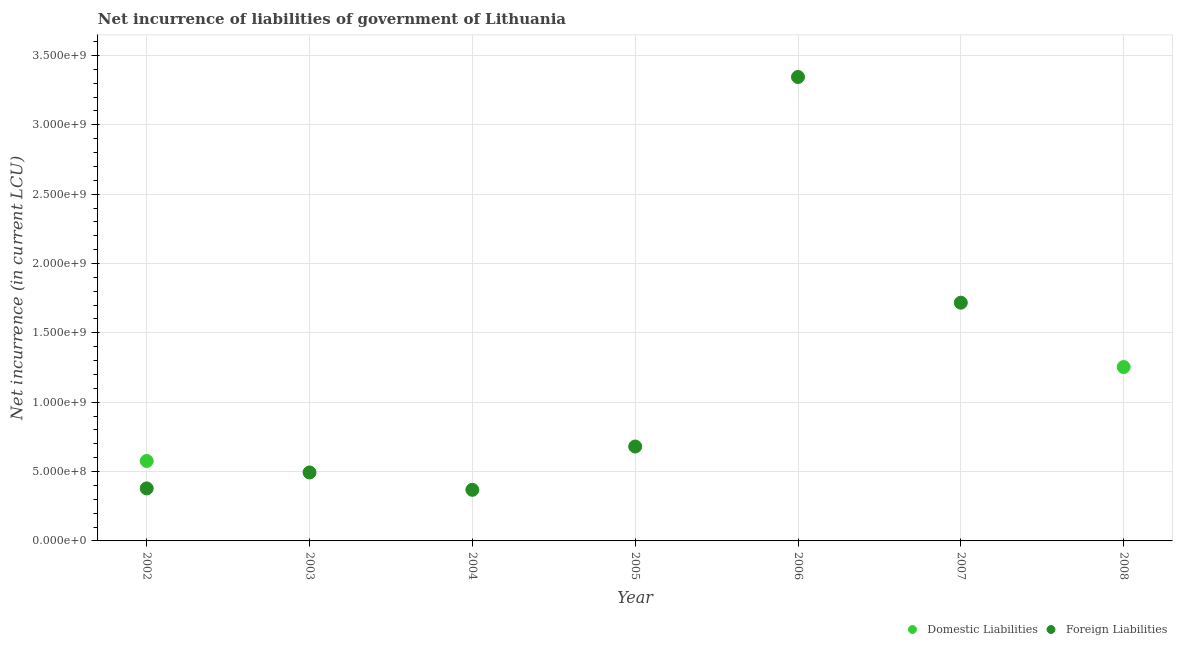What is the net incurrence of domestic liabilities in 2007?
Offer a very short reply. 0. Across all years, what is the maximum net incurrence of foreign liabilities?
Your response must be concise. 3.34e+09. Across all years, what is the minimum net incurrence of domestic liabilities?
Give a very brief answer. 0. In which year was the net incurrence of domestic liabilities maximum?
Keep it short and to the point. 2008. What is the total net incurrence of domestic liabilities in the graph?
Ensure brevity in your answer.  1.83e+09. What is the difference between the net incurrence of foreign liabilities in 2002 and that in 2006?
Your answer should be compact. -2.97e+09. What is the difference between the net incurrence of domestic liabilities in 2003 and the net incurrence of foreign liabilities in 2007?
Provide a succinct answer. -1.72e+09. What is the average net incurrence of foreign liabilities per year?
Ensure brevity in your answer.  9.98e+08. In the year 2002, what is the difference between the net incurrence of domestic liabilities and net incurrence of foreign liabilities?
Your answer should be compact. 1.98e+08. In how many years, is the net incurrence of foreign liabilities greater than 3300000000 LCU?
Keep it short and to the point. 1. What is the ratio of the net incurrence of foreign liabilities in 2002 to that in 2003?
Ensure brevity in your answer.  0.77. Is the net incurrence of foreign liabilities in 2002 less than that in 2003?
Offer a terse response. Yes. What is the difference between the highest and the second highest net incurrence of foreign liabilities?
Provide a short and direct response. 1.63e+09. What is the difference between the highest and the lowest net incurrence of domestic liabilities?
Offer a very short reply. 1.25e+09. Is the net incurrence of domestic liabilities strictly greater than the net incurrence of foreign liabilities over the years?
Make the answer very short. No. Is the net incurrence of foreign liabilities strictly less than the net incurrence of domestic liabilities over the years?
Make the answer very short. No. How many years are there in the graph?
Make the answer very short. 7. Are the values on the major ticks of Y-axis written in scientific E-notation?
Offer a very short reply. Yes. Does the graph contain any zero values?
Offer a terse response. Yes. Does the graph contain grids?
Make the answer very short. Yes. Where does the legend appear in the graph?
Your answer should be compact. Bottom right. How are the legend labels stacked?
Give a very brief answer. Horizontal. What is the title of the graph?
Keep it short and to the point. Net incurrence of liabilities of government of Lithuania. What is the label or title of the X-axis?
Your answer should be compact. Year. What is the label or title of the Y-axis?
Your answer should be compact. Net incurrence (in current LCU). What is the Net incurrence (in current LCU) of Domestic Liabilities in 2002?
Give a very brief answer. 5.76e+08. What is the Net incurrence (in current LCU) of Foreign Liabilities in 2002?
Keep it short and to the point. 3.79e+08. What is the Net incurrence (in current LCU) of Domestic Liabilities in 2003?
Your answer should be very brief. 0. What is the Net incurrence (in current LCU) of Foreign Liabilities in 2003?
Offer a terse response. 4.94e+08. What is the Net incurrence (in current LCU) of Foreign Liabilities in 2004?
Your answer should be very brief. 3.68e+08. What is the Net incurrence (in current LCU) in Foreign Liabilities in 2005?
Your answer should be very brief. 6.81e+08. What is the Net incurrence (in current LCU) in Domestic Liabilities in 2006?
Provide a short and direct response. 0. What is the Net incurrence (in current LCU) in Foreign Liabilities in 2006?
Ensure brevity in your answer.  3.34e+09. What is the Net incurrence (in current LCU) in Foreign Liabilities in 2007?
Ensure brevity in your answer.  1.72e+09. What is the Net incurrence (in current LCU) of Domestic Liabilities in 2008?
Ensure brevity in your answer.  1.25e+09. What is the Net incurrence (in current LCU) of Foreign Liabilities in 2008?
Offer a very short reply. 0. Across all years, what is the maximum Net incurrence (in current LCU) in Domestic Liabilities?
Provide a short and direct response. 1.25e+09. Across all years, what is the maximum Net incurrence (in current LCU) of Foreign Liabilities?
Your answer should be compact. 3.34e+09. Across all years, what is the minimum Net incurrence (in current LCU) in Domestic Liabilities?
Make the answer very short. 0. What is the total Net incurrence (in current LCU) in Domestic Liabilities in the graph?
Provide a succinct answer. 1.83e+09. What is the total Net incurrence (in current LCU) of Foreign Liabilities in the graph?
Provide a short and direct response. 6.98e+09. What is the difference between the Net incurrence (in current LCU) of Foreign Liabilities in 2002 and that in 2003?
Keep it short and to the point. -1.15e+08. What is the difference between the Net incurrence (in current LCU) in Foreign Liabilities in 2002 and that in 2004?
Offer a very short reply. 1.02e+07. What is the difference between the Net incurrence (in current LCU) in Foreign Liabilities in 2002 and that in 2005?
Provide a short and direct response. -3.02e+08. What is the difference between the Net incurrence (in current LCU) in Foreign Liabilities in 2002 and that in 2006?
Your answer should be compact. -2.97e+09. What is the difference between the Net incurrence (in current LCU) of Foreign Liabilities in 2002 and that in 2007?
Make the answer very short. -1.34e+09. What is the difference between the Net incurrence (in current LCU) in Domestic Liabilities in 2002 and that in 2008?
Offer a terse response. -6.77e+08. What is the difference between the Net incurrence (in current LCU) in Foreign Liabilities in 2003 and that in 2004?
Ensure brevity in your answer.  1.25e+08. What is the difference between the Net incurrence (in current LCU) of Foreign Liabilities in 2003 and that in 2005?
Offer a very short reply. -1.87e+08. What is the difference between the Net incurrence (in current LCU) in Foreign Liabilities in 2003 and that in 2006?
Make the answer very short. -2.85e+09. What is the difference between the Net incurrence (in current LCU) of Foreign Liabilities in 2003 and that in 2007?
Keep it short and to the point. -1.22e+09. What is the difference between the Net incurrence (in current LCU) in Foreign Liabilities in 2004 and that in 2005?
Provide a short and direct response. -3.12e+08. What is the difference between the Net incurrence (in current LCU) in Foreign Liabilities in 2004 and that in 2006?
Your answer should be compact. -2.98e+09. What is the difference between the Net incurrence (in current LCU) of Foreign Liabilities in 2004 and that in 2007?
Your response must be concise. -1.35e+09. What is the difference between the Net incurrence (in current LCU) of Foreign Liabilities in 2005 and that in 2006?
Provide a succinct answer. -2.66e+09. What is the difference between the Net incurrence (in current LCU) in Foreign Liabilities in 2005 and that in 2007?
Provide a short and direct response. -1.04e+09. What is the difference between the Net incurrence (in current LCU) in Foreign Liabilities in 2006 and that in 2007?
Ensure brevity in your answer.  1.63e+09. What is the difference between the Net incurrence (in current LCU) in Domestic Liabilities in 2002 and the Net incurrence (in current LCU) in Foreign Liabilities in 2003?
Your answer should be very brief. 8.26e+07. What is the difference between the Net incurrence (in current LCU) in Domestic Liabilities in 2002 and the Net incurrence (in current LCU) in Foreign Liabilities in 2004?
Offer a terse response. 2.08e+08. What is the difference between the Net incurrence (in current LCU) of Domestic Liabilities in 2002 and the Net incurrence (in current LCU) of Foreign Liabilities in 2005?
Give a very brief answer. -1.04e+08. What is the difference between the Net incurrence (in current LCU) in Domestic Liabilities in 2002 and the Net incurrence (in current LCU) in Foreign Liabilities in 2006?
Ensure brevity in your answer.  -2.77e+09. What is the difference between the Net incurrence (in current LCU) in Domestic Liabilities in 2002 and the Net incurrence (in current LCU) in Foreign Liabilities in 2007?
Give a very brief answer. -1.14e+09. What is the average Net incurrence (in current LCU) of Domestic Liabilities per year?
Give a very brief answer. 2.61e+08. What is the average Net incurrence (in current LCU) of Foreign Liabilities per year?
Your answer should be very brief. 9.98e+08. In the year 2002, what is the difference between the Net incurrence (in current LCU) of Domestic Liabilities and Net incurrence (in current LCU) of Foreign Liabilities?
Provide a short and direct response. 1.98e+08. What is the ratio of the Net incurrence (in current LCU) in Foreign Liabilities in 2002 to that in 2003?
Your answer should be very brief. 0.77. What is the ratio of the Net incurrence (in current LCU) of Foreign Liabilities in 2002 to that in 2004?
Your answer should be very brief. 1.03. What is the ratio of the Net incurrence (in current LCU) of Foreign Liabilities in 2002 to that in 2005?
Ensure brevity in your answer.  0.56. What is the ratio of the Net incurrence (in current LCU) in Foreign Liabilities in 2002 to that in 2006?
Provide a short and direct response. 0.11. What is the ratio of the Net incurrence (in current LCU) of Foreign Liabilities in 2002 to that in 2007?
Ensure brevity in your answer.  0.22. What is the ratio of the Net incurrence (in current LCU) of Domestic Liabilities in 2002 to that in 2008?
Keep it short and to the point. 0.46. What is the ratio of the Net incurrence (in current LCU) in Foreign Liabilities in 2003 to that in 2004?
Your response must be concise. 1.34. What is the ratio of the Net incurrence (in current LCU) of Foreign Liabilities in 2003 to that in 2005?
Provide a succinct answer. 0.73. What is the ratio of the Net incurrence (in current LCU) in Foreign Liabilities in 2003 to that in 2006?
Provide a succinct answer. 0.15. What is the ratio of the Net incurrence (in current LCU) in Foreign Liabilities in 2003 to that in 2007?
Provide a succinct answer. 0.29. What is the ratio of the Net incurrence (in current LCU) of Foreign Liabilities in 2004 to that in 2005?
Offer a terse response. 0.54. What is the ratio of the Net incurrence (in current LCU) in Foreign Liabilities in 2004 to that in 2006?
Your answer should be compact. 0.11. What is the ratio of the Net incurrence (in current LCU) of Foreign Liabilities in 2004 to that in 2007?
Offer a very short reply. 0.21. What is the ratio of the Net incurrence (in current LCU) of Foreign Liabilities in 2005 to that in 2006?
Your answer should be compact. 0.2. What is the ratio of the Net incurrence (in current LCU) of Foreign Liabilities in 2005 to that in 2007?
Your response must be concise. 0.4. What is the ratio of the Net incurrence (in current LCU) of Foreign Liabilities in 2006 to that in 2007?
Provide a short and direct response. 1.95. What is the difference between the highest and the second highest Net incurrence (in current LCU) of Foreign Liabilities?
Your answer should be very brief. 1.63e+09. What is the difference between the highest and the lowest Net incurrence (in current LCU) in Domestic Liabilities?
Offer a terse response. 1.25e+09. What is the difference between the highest and the lowest Net incurrence (in current LCU) in Foreign Liabilities?
Your answer should be very brief. 3.34e+09. 